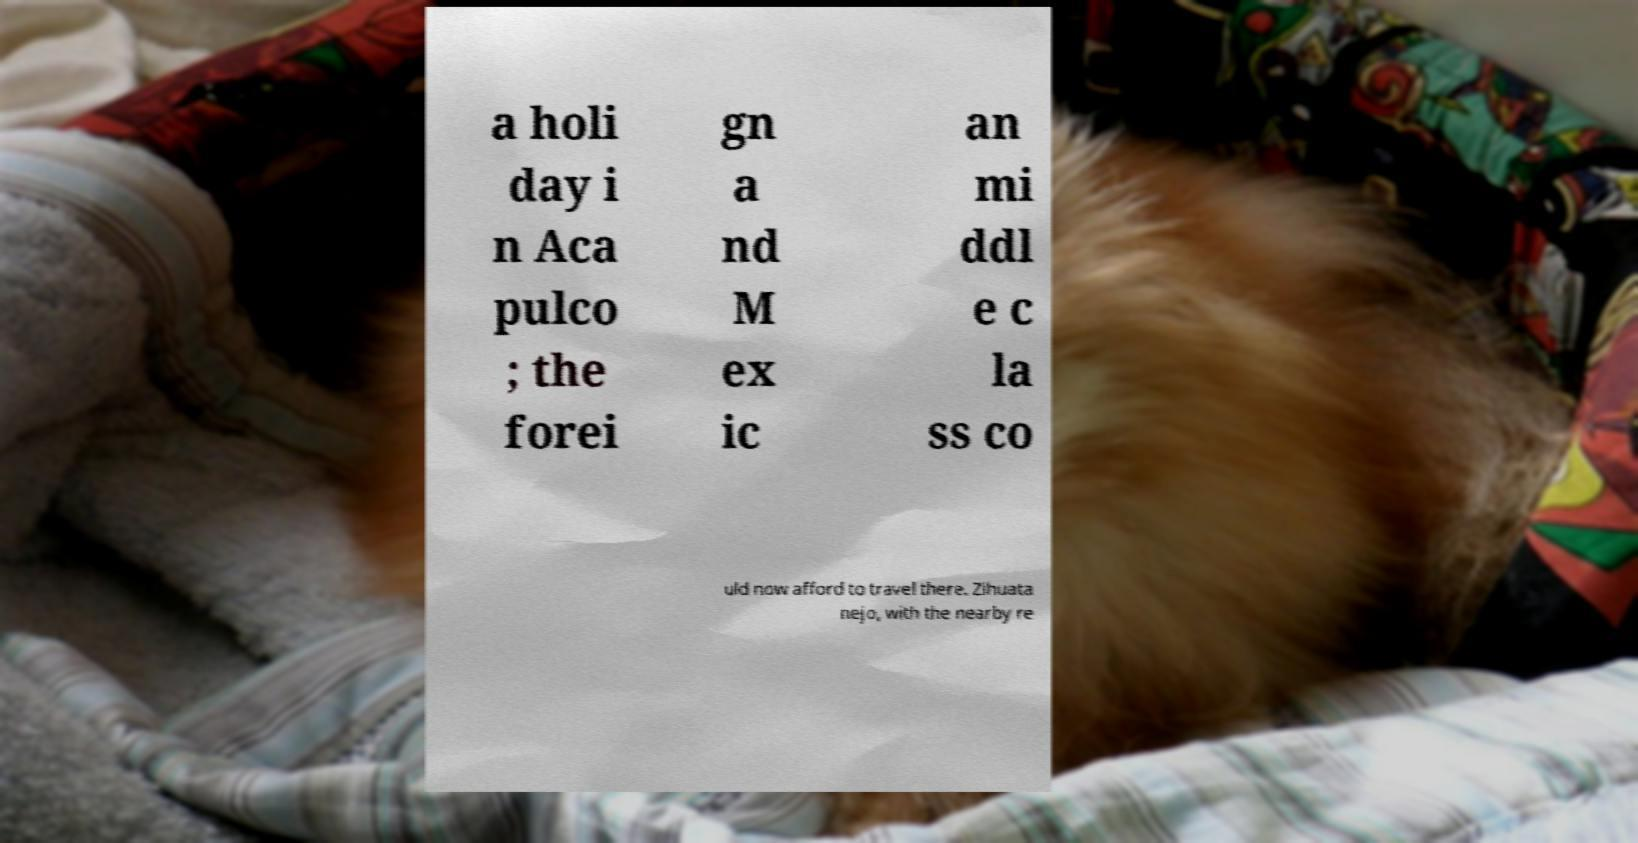For documentation purposes, I need the text within this image transcribed. Could you provide that? a holi day i n Aca pulco ; the forei gn a nd M ex ic an mi ddl e c la ss co uld now afford to travel there. Zihuata nejo, with the nearby re 